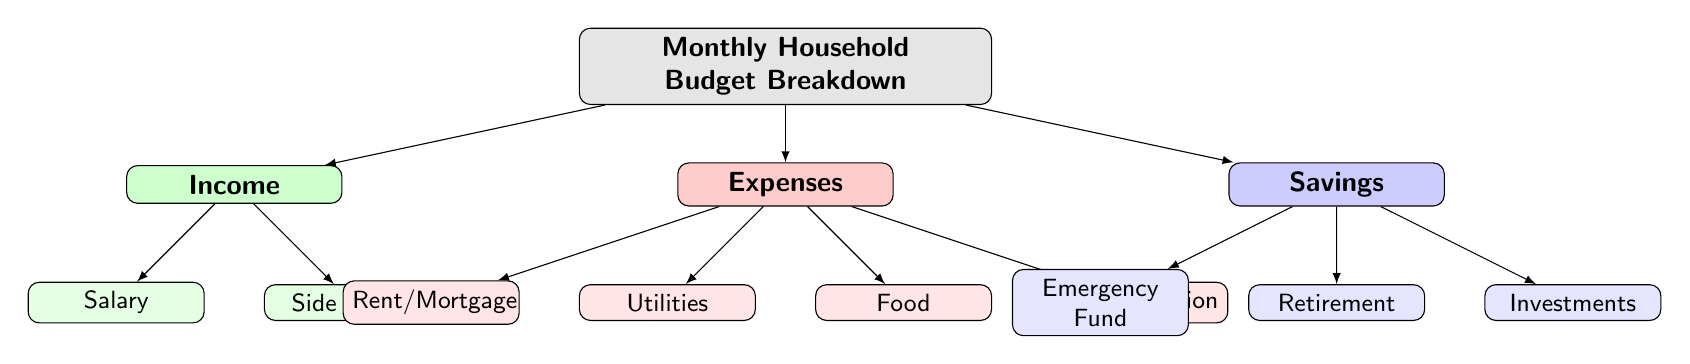What are the main categories of the budget? The diagram indicates three main categories: Income, Expenses, and Savings.
Answer: Income, Expenses, Savings How many subcategories are under Expenses? The diagram shows four subcategories listed under Expenses: Rent/Mortgage, Utilities, Food, and Transportation.
Answer: 4 What color represents the Savings category? The Savings category is represented by the color blue, as indicated in the diagram.
Answer: Blue Which source of Income is listed first? The first source of Income shown in the diagram is Salary, which is positioned at the top of the Income branch.
Answer: Salary Which subcategory of Savings is focused on future planning? The subcategory focused on future planning under Savings is Retirement.
Answer: Retirement What do the nodes in green represent? The nodes in green represent the Income category, which includes Salary and Side Hustle as sources of income.
Answer: Income How many total subcategories are there in the diagram? The diagram comprises a total of seven subcategories: two under Income, four under Expenses, and three under Savings.
Answer: 7 Which category has the most subcategories? The Expenses category holds the most subcategories, with a total of four listed under it.
Answer: Expenses What is the relationship between the Expenses and Income categories? The relationship shows that Expenses are a distinct category separate from Income, suggesting that households allocate a portion of their Income to cover their Expenses.
Answer: Separate categories 